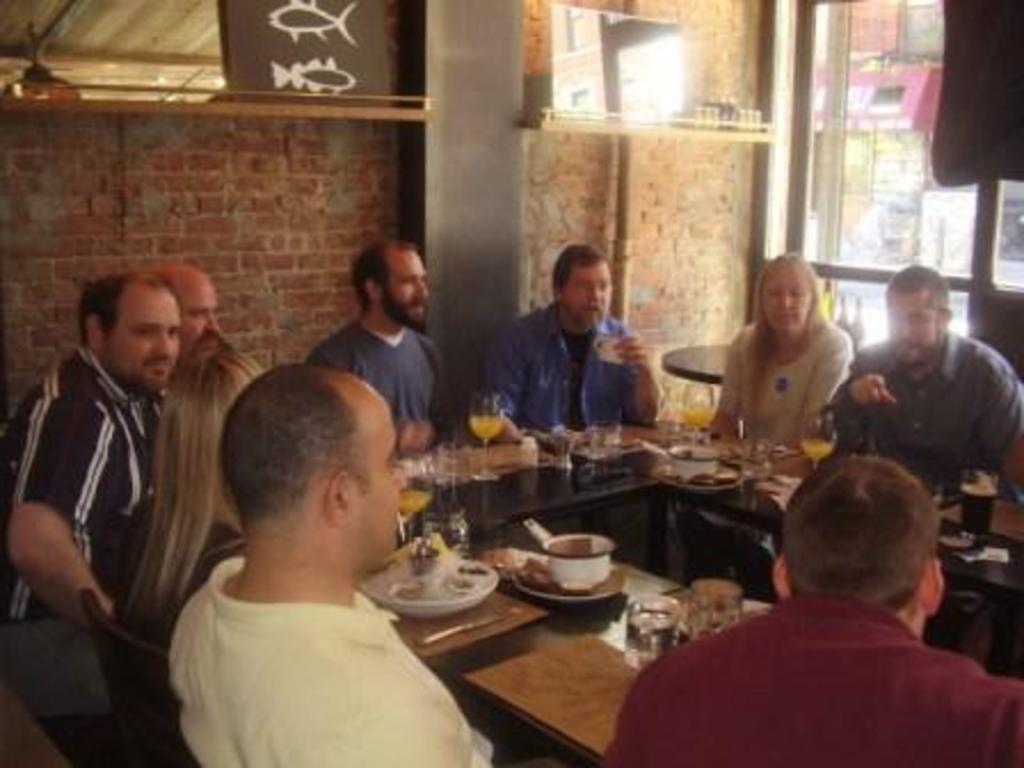Can you describe this image briefly? This image consists of many people sitting around the table. On the table, we can see many plates, bowls, and glasses. In the background, there is a wall along with a pillar. On the right, there are windows. 